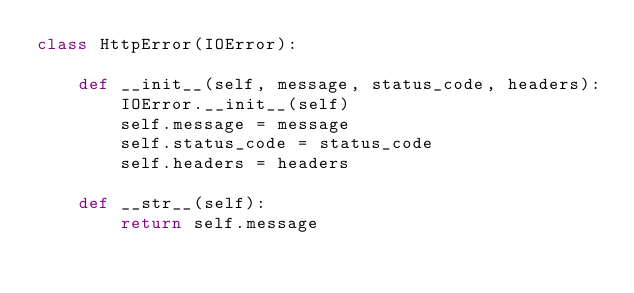Convert code to text. <code><loc_0><loc_0><loc_500><loc_500><_Python_>class HttpError(IOError):

    def __init__(self, message, status_code, headers):
        IOError.__init__(self)
        self.message = message
        self.status_code = status_code
        self.headers = headers

    def __str__(self):
        return self.message
</code> 